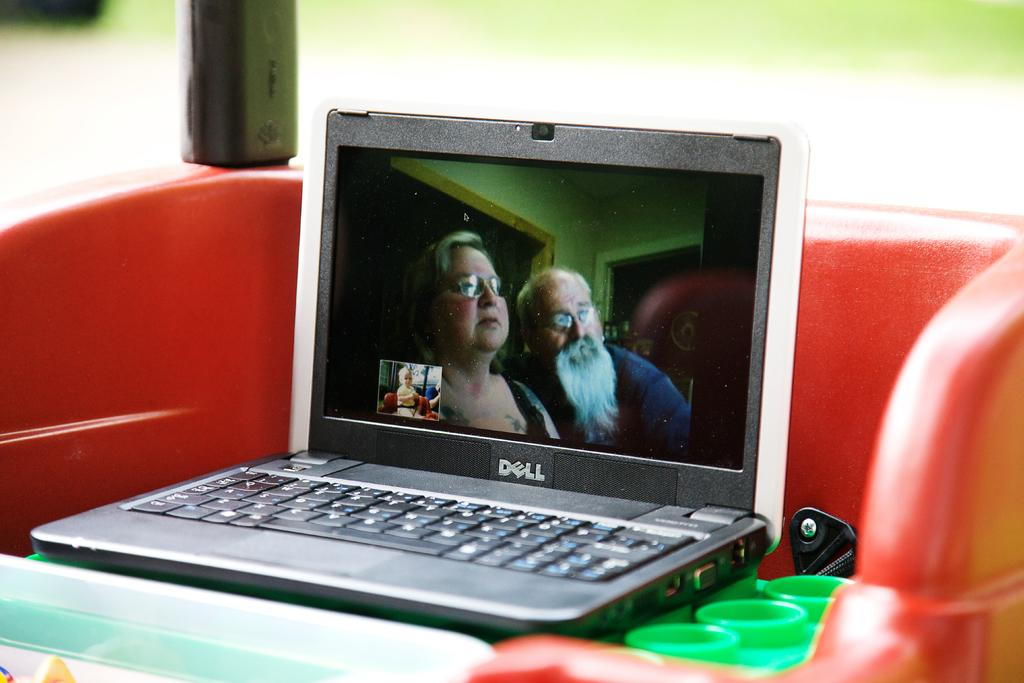<image>
Share a concise interpretation of the image provided. A movie is being played on a Dell laptop. 